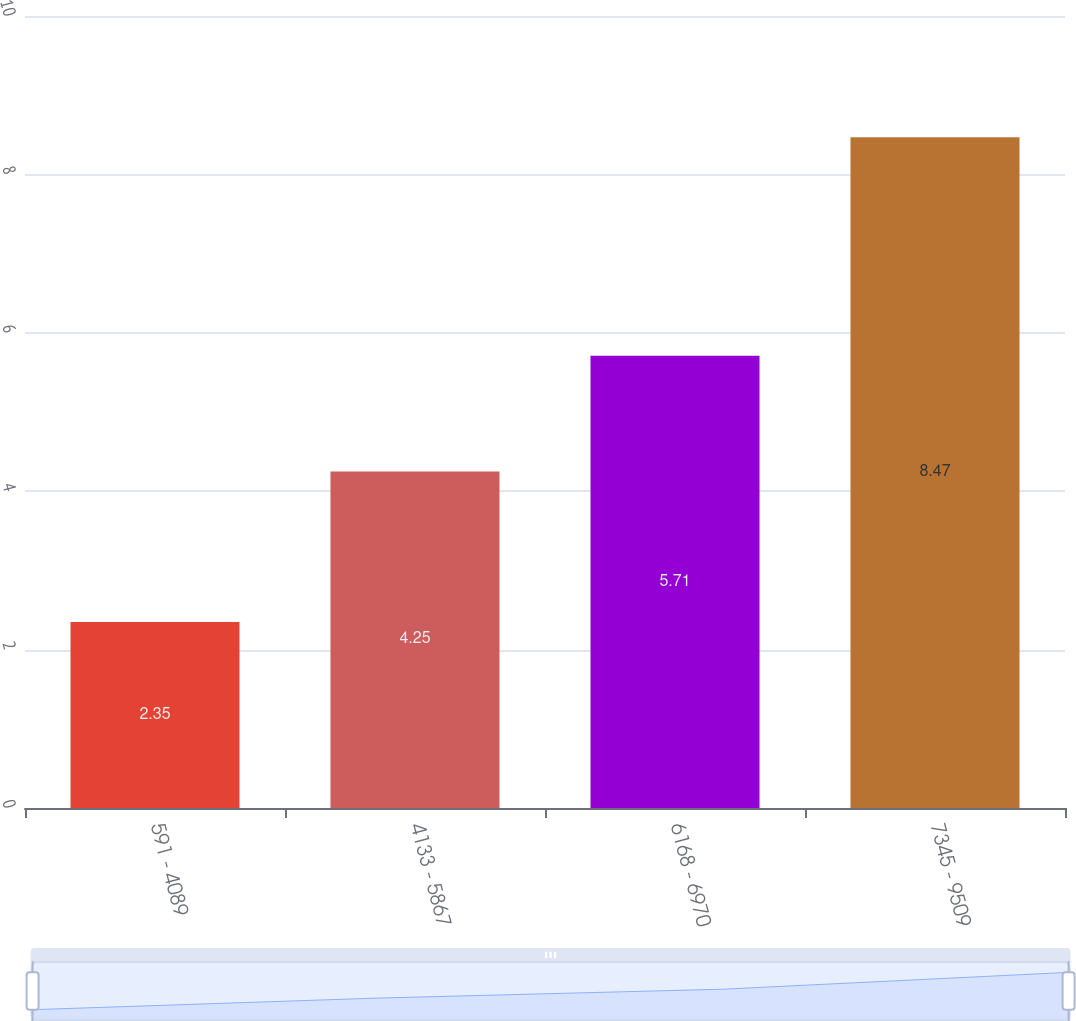Convert chart to OTSL. <chart><loc_0><loc_0><loc_500><loc_500><bar_chart><fcel>591 - 4089<fcel>4133 - 5867<fcel>6168 - 6970<fcel>7345 - 9509<nl><fcel>2.35<fcel>4.25<fcel>5.71<fcel>8.47<nl></chart> 